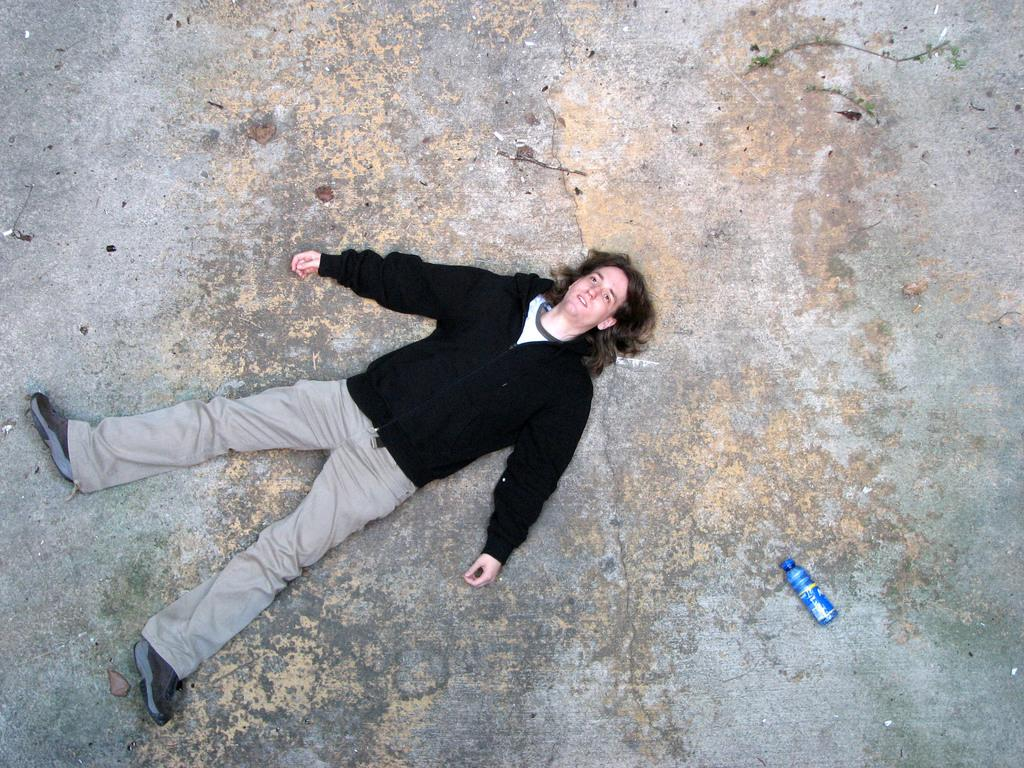What is the primary subject in the image? There is a person in the image. What is the person's location in the image? The person is on the cement floor. What object can be seen in the bottom right of the image? There is a bottle in the bottom right of the image. What is the person saying in the image? There is no dialogue or speech visible in the image, so it is not possible to determine what the person might be saying. 